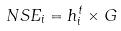Convert formula to latex. <formula><loc_0><loc_0><loc_500><loc_500>N S E _ { i } = h _ { i } ^ { t } \times G</formula> 